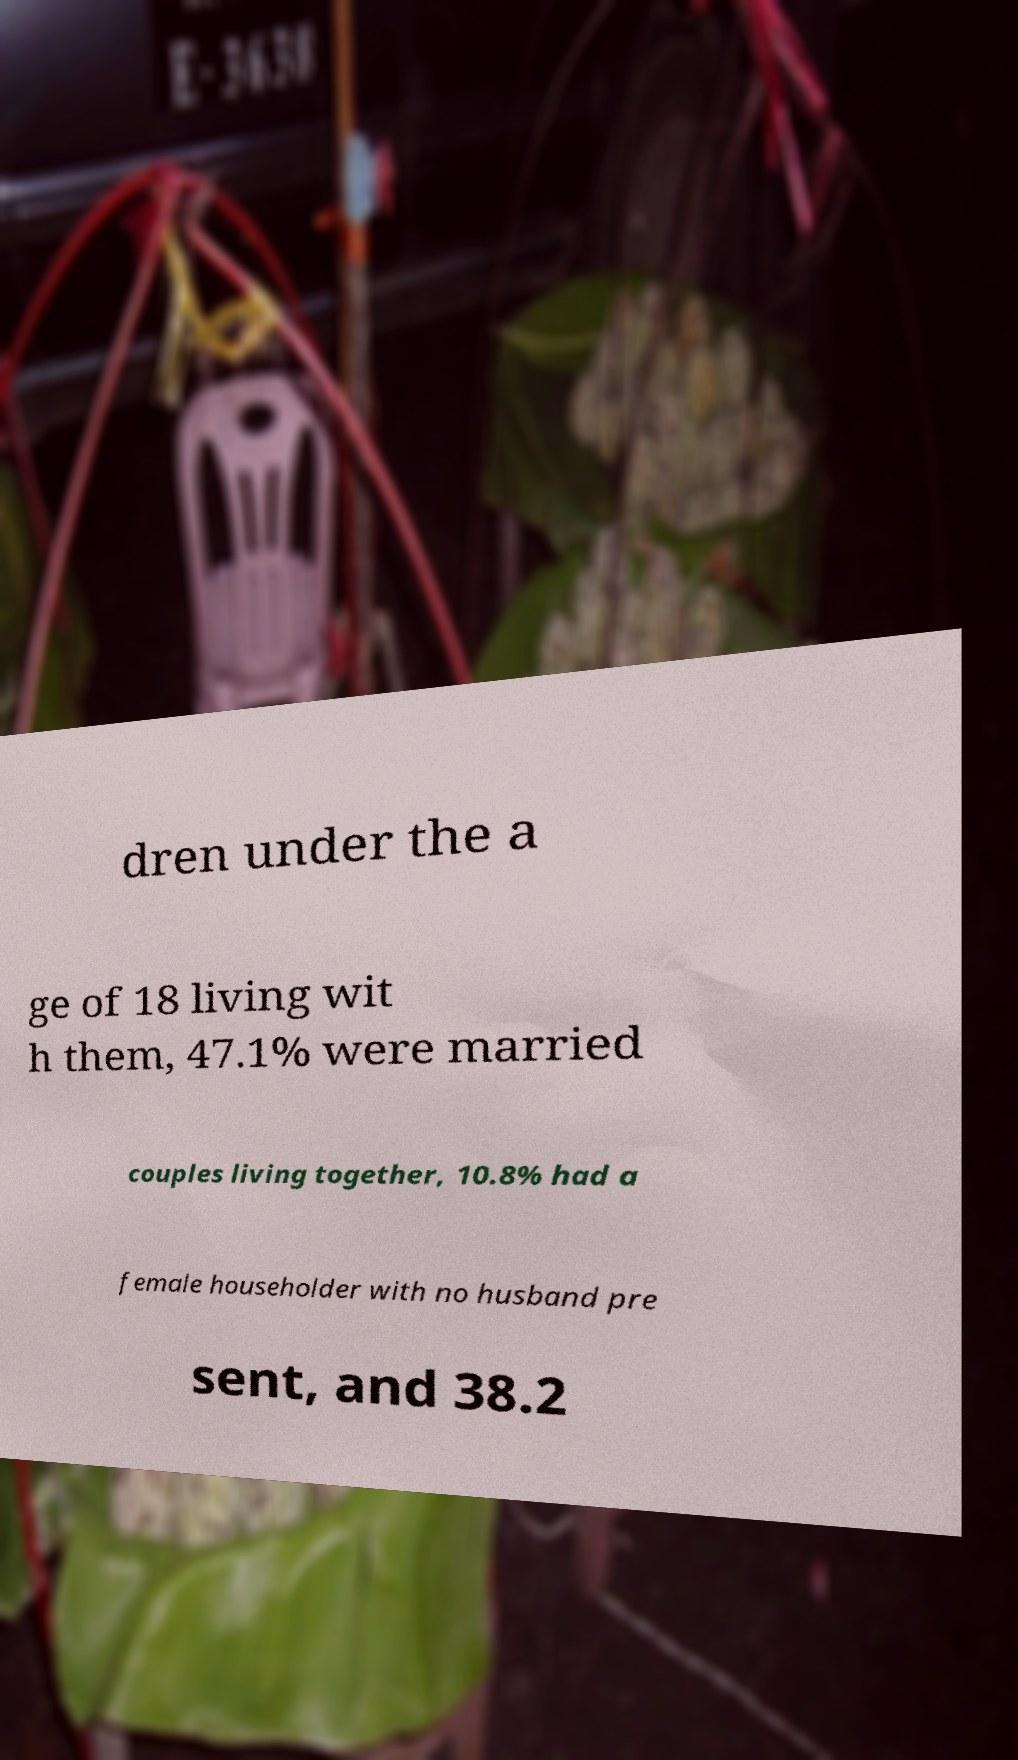Can you read and provide the text displayed in the image?This photo seems to have some interesting text. Can you extract and type it out for me? dren under the a ge of 18 living wit h them, 47.1% were married couples living together, 10.8% had a female householder with no husband pre sent, and 38.2 